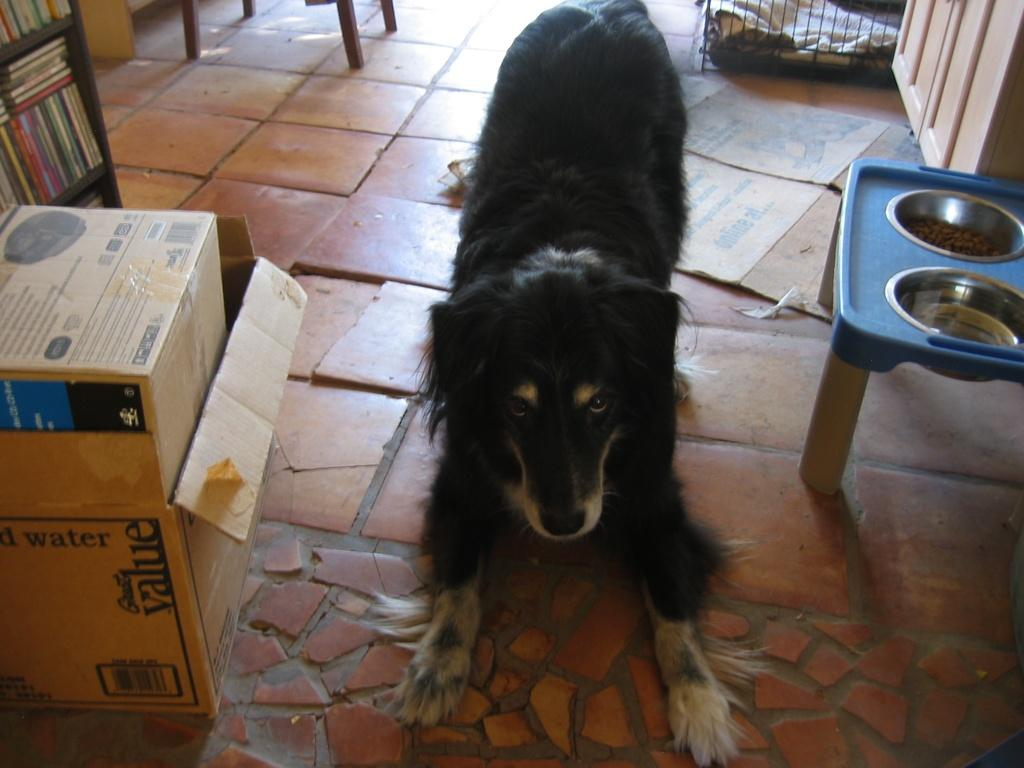What type of animal is in the image? There is a black dog in the image. What is located at the right side of the image? There is a bowl with pedigree at the right side of the image. What is located at the left side of the image? There is a brown cardboard box at the left side of the image. How many eyes can be seen on the engine in the image? There is no engine present in the image, so it is not possible to determine the number of eyes on it. 